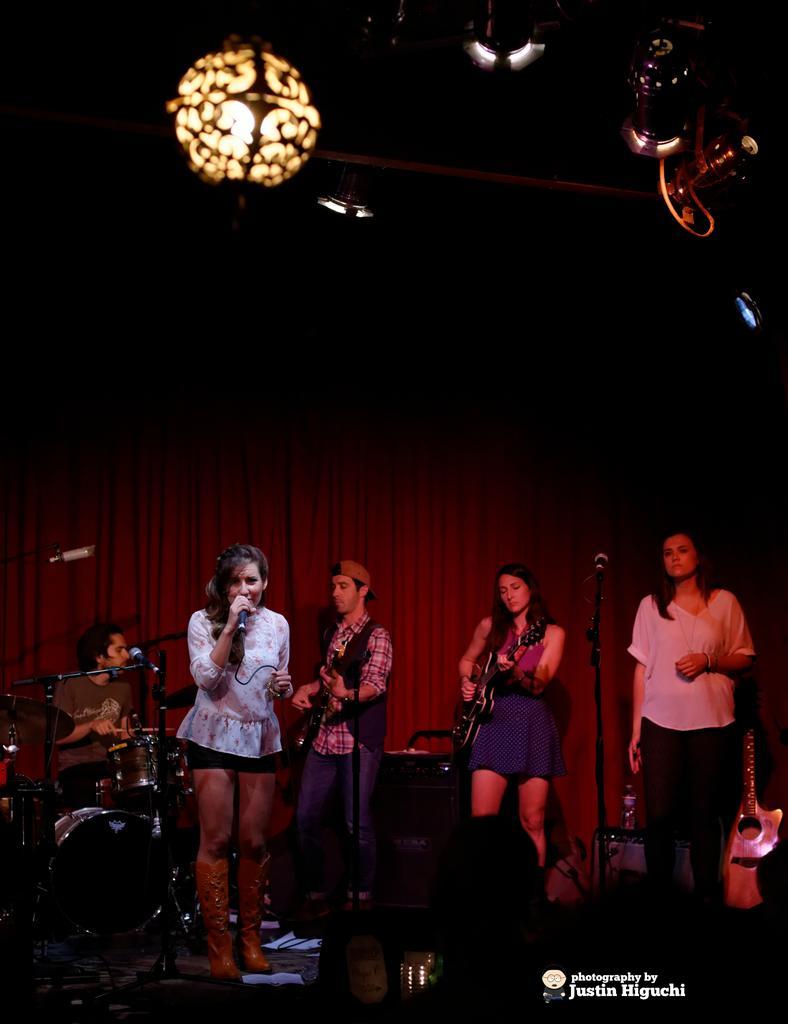Can you describe this image briefly? In this image i can see three women standing and a man standing and playing guitar the women sitting here is playing drums, the woman standing in the front singing song holding a micro phone, the woman standing at the right playing a guitar at the back ground i can see a curtain, at the top i can see a light. 